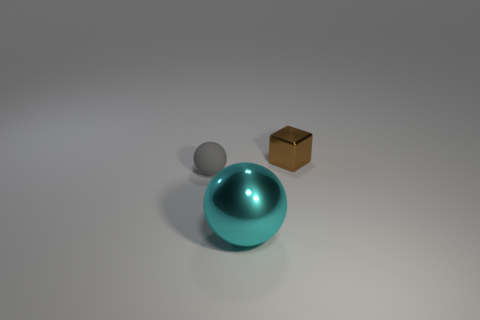Add 2 tiny cyan metallic things. How many objects exist? 5 Subtract all blocks. How many objects are left? 2 Subtract all small green shiny spheres. Subtract all rubber things. How many objects are left? 2 Add 2 small brown metal things. How many small brown metal things are left? 3 Add 1 brown shiny objects. How many brown shiny objects exist? 2 Subtract 0 blue cubes. How many objects are left? 3 